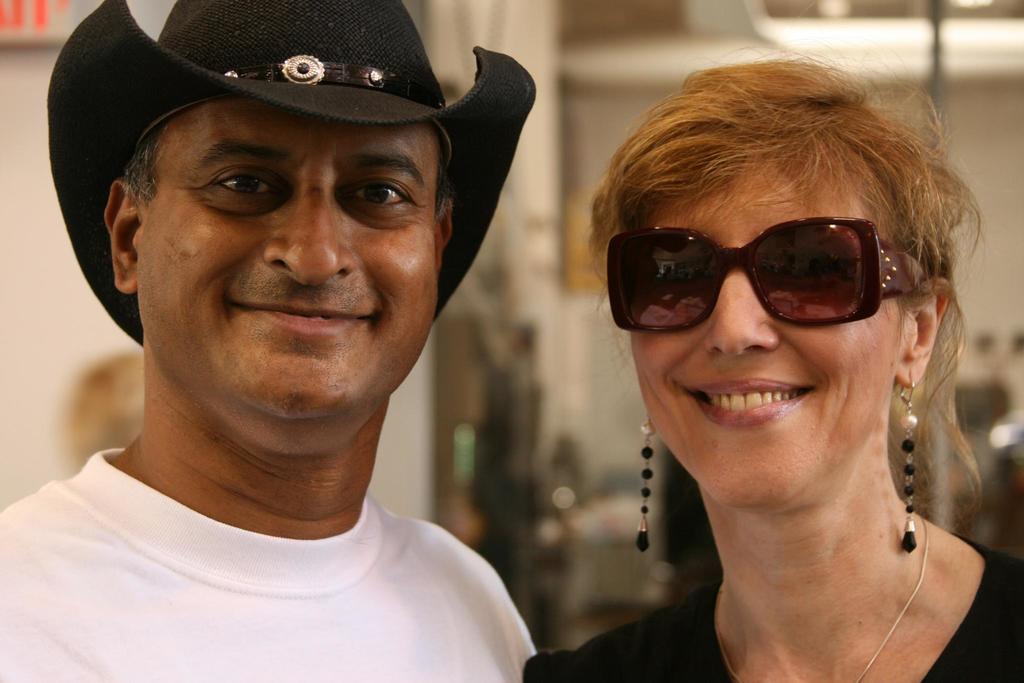Please provide a concise description of this image. In this image we can see a man wearing the hat and also the woman wearing the glasses and smiling and the background is blurred. We can also see the lights. 